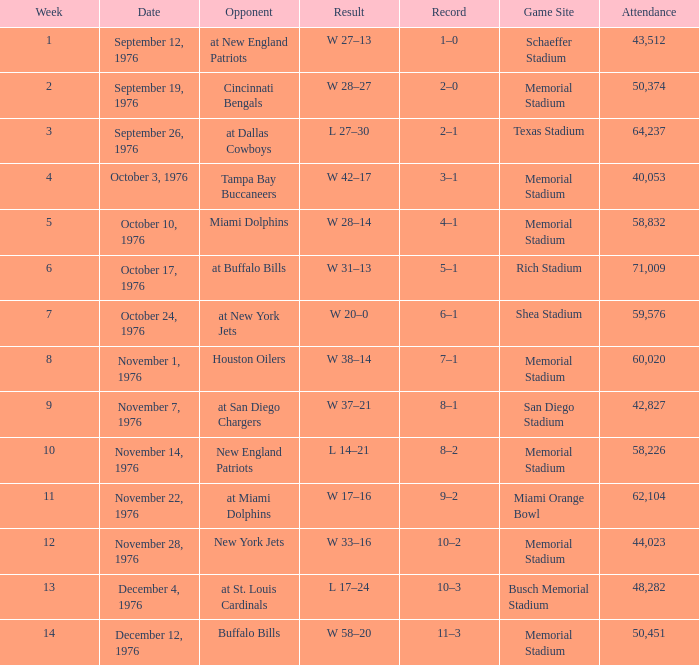Can you parse all the data within this table? {'header': ['Week', 'Date', 'Opponent', 'Result', 'Record', 'Game Site', 'Attendance'], 'rows': [['1', 'September 12, 1976', 'at New England Patriots', 'W 27–13', '1–0', 'Schaeffer Stadium', '43,512'], ['2', 'September 19, 1976', 'Cincinnati Bengals', 'W 28–27', '2–0', 'Memorial Stadium', '50,374'], ['3', 'September 26, 1976', 'at Dallas Cowboys', 'L 27–30', '2–1', 'Texas Stadium', '64,237'], ['4', 'October 3, 1976', 'Tampa Bay Buccaneers', 'W 42–17', '3–1', 'Memorial Stadium', '40,053'], ['5', 'October 10, 1976', 'Miami Dolphins', 'W 28–14', '4–1', 'Memorial Stadium', '58,832'], ['6', 'October 17, 1976', 'at Buffalo Bills', 'W 31–13', '5–1', 'Rich Stadium', '71,009'], ['7', 'October 24, 1976', 'at New York Jets', 'W 20–0', '6–1', 'Shea Stadium', '59,576'], ['8', 'November 1, 1976', 'Houston Oilers', 'W 38–14', '7–1', 'Memorial Stadium', '60,020'], ['9', 'November 7, 1976', 'at San Diego Chargers', 'W 37–21', '8–1', 'San Diego Stadium', '42,827'], ['10', 'November 14, 1976', 'New England Patriots', 'L 14–21', '8–2', 'Memorial Stadium', '58,226'], ['11', 'November 22, 1976', 'at Miami Dolphins', 'W 17–16', '9–2', 'Miami Orange Bowl', '62,104'], ['12', 'November 28, 1976', 'New York Jets', 'W 33–16', '10–2', 'Memorial Stadium', '44,023'], ['13', 'December 4, 1976', 'at St. Louis Cardinals', 'L 17–24', '10–3', 'Busch Memorial Stadium', '48,282'], ['14', 'December 12, 1976', 'Buffalo Bills', 'W 58–20', '11–3', 'Memorial Stadium', '50,451']]} How many people attended the game at the miami orange bowl? 62104.0. 